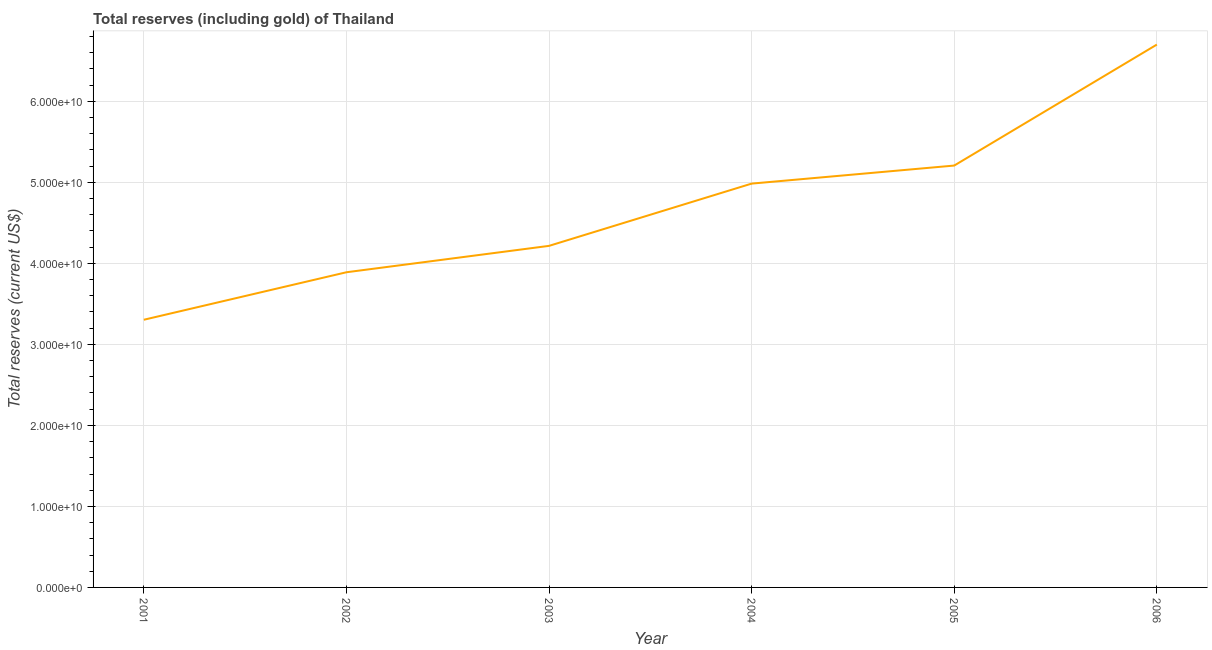What is the total reserves (including gold) in 2003?
Provide a succinct answer. 4.22e+1. Across all years, what is the maximum total reserves (including gold)?
Give a very brief answer. 6.70e+1. Across all years, what is the minimum total reserves (including gold)?
Your response must be concise. 3.30e+1. In which year was the total reserves (including gold) minimum?
Your answer should be very brief. 2001. What is the sum of the total reserves (including gold)?
Provide a succinct answer. 2.83e+11. What is the difference between the total reserves (including gold) in 2003 and 2005?
Your answer should be very brief. -9.91e+09. What is the average total reserves (including gold) per year?
Keep it short and to the point. 4.72e+1. What is the median total reserves (including gold)?
Your response must be concise. 4.60e+1. What is the ratio of the total reserves (including gold) in 2002 to that in 2005?
Offer a very short reply. 0.75. What is the difference between the highest and the second highest total reserves (including gold)?
Your response must be concise. 1.49e+1. Is the sum of the total reserves (including gold) in 2004 and 2005 greater than the maximum total reserves (including gold) across all years?
Make the answer very short. Yes. What is the difference between the highest and the lowest total reserves (including gold)?
Provide a succinct answer. 3.40e+1. Does the total reserves (including gold) monotonically increase over the years?
Your answer should be compact. Yes. How many lines are there?
Offer a terse response. 1. What is the difference between two consecutive major ticks on the Y-axis?
Give a very brief answer. 1.00e+1. Are the values on the major ticks of Y-axis written in scientific E-notation?
Make the answer very short. Yes. Does the graph contain grids?
Your answer should be very brief. Yes. What is the title of the graph?
Give a very brief answer. Total reserves (including gold) of Thailand. What is the label or title of the Y-axis?
Your response must be concise. Total reserves (current US$). What is the Total reserves (current US$) of 2001?
Provide a succinct answer. 3.30e+1. What is the Total reserves (current US$) of 2002?
Offer a terse response. 3.89e+1. What is the Total reserves (current US$) in 2003?
Give a very brief answer. 4.22e+1. What is the Total reserves (current US$) of 2004?
Give a very brief answer. 4.98e+1. What is the Total reserves (current US$) of 2005?
Offer a terse response. 5.21e+1. What is the Total reserves (current US$) in 2006?
Your answer should be compact. 6.70e+1. What is the difference between the Total reserves (current US$) in 2001 and 2002?
Your response must be concise. -5.86e+09. What is the difference between the Total reserves (current US$) in 2001 and 2003?
Provide a succinct answer. -9.12e+09. What is the difference between the Total reserves (current US$) in 2001 and 2004?
Offer a very short reply. -1.68e+1. What is the difference between the Total reserves (current US$) in 2001 and 2005?
Your response must be concise. -1.90e+1. What is the difference between the Total reserves (current US$) in 2001 and 2006?
Provide a succinct answer. -3.40e+1. What is the difference between the Total reserves (current US$) in 2002 and 2003?
Make the answer very short. -3.26e+09. What is the difference between the Total reserves (current US$) in 2002 and 2004?
Keep it short and to the point. -1.09e+1. What is the difference between the Total reserves (current US$) in 2002 and 2005?
Provide a succinct answer. -1.32e+1. What is the difference between the Total reserves (current US$) in 2002 and 2006?
Your answer should be very brief. -2.81e+1. What is the difference between the Total reserves (current US$) in 2003 and 2004?
Make the answer very short. -7.68e+09. What is the difference between the Total reserves (current US$) in 2003 and 2005?
Your answer should be compact. -9.91e+09. What is the difference between the Total reserves (current US$) in 2003 and 2006?
Your response must be concise. -2.48e+1. What is the difference between the Total reserves (current US$) in 2004 and 2005?
Provide a short and direct response. -2.23e+09. What is the difference between the Total reserves (current US$) in 2004 and 2006?
Make the answer very short. -1.72e+1. What is the difference between the Total reserves (current US$) in 2005 and 2006?
Offer a terse response. -1.49e+1. What is the ratio of the Total reserves (current US$) in 2001 to that in 2002?
Ensure brevity in your answer.  0.85. What is the ratio of the Total reserves (current US$) in 2001 to that in 2003?
Your answer should be very brief. 0.78. What is the ratio of the Total reserves (current US$) in 2001 to that in 2004?
Your answer should be compact. 0.66. What is the ratio of the Total reserves (current US$) in 2001 to that in 2005?
Keep it short and to the point. 0.63. What is the ratio of the Total reserves (current US$) in 2001 to that in 2006?
Keep it short and to the point. 0.49. What is the ratio of the Total reserves (current US$) in 2002 to that in 2003?
Your answer should be compact. 0.92. What is the ratio of the Total reserves (current US$) in 2002 to that in 2004?
Make the answer very short. 0.78. What is the ratio of the Total reserves (current US$) in 2002 to that in 2005?
Your answer should be very brief. 0.75. What is the ratio of the Total reserves (current US$) in 2002 to that in 2006?
Your response must be concise. 0.58. What is the ratio of the Total reserves (current US$) in 2003 to that in 2004?
Your answer should be very brief. 0.85. What is the ratio of the Total reserves (current US$) in 2003 to that in 2005?
Your response must be concise. 0.81. What is the ratio of the Total reserves (current US$) in 2003 to that in 2006?
Offer a very short reply. 0.63. What is the ratio of the Total reserves (current US$) in 2004 to that in 2006?
Offer a terse response. 0.74. What is the ratio of the Total reserves (current US$) in 2005 to that in 2006?
Provide a succinct answer. 0.78. 